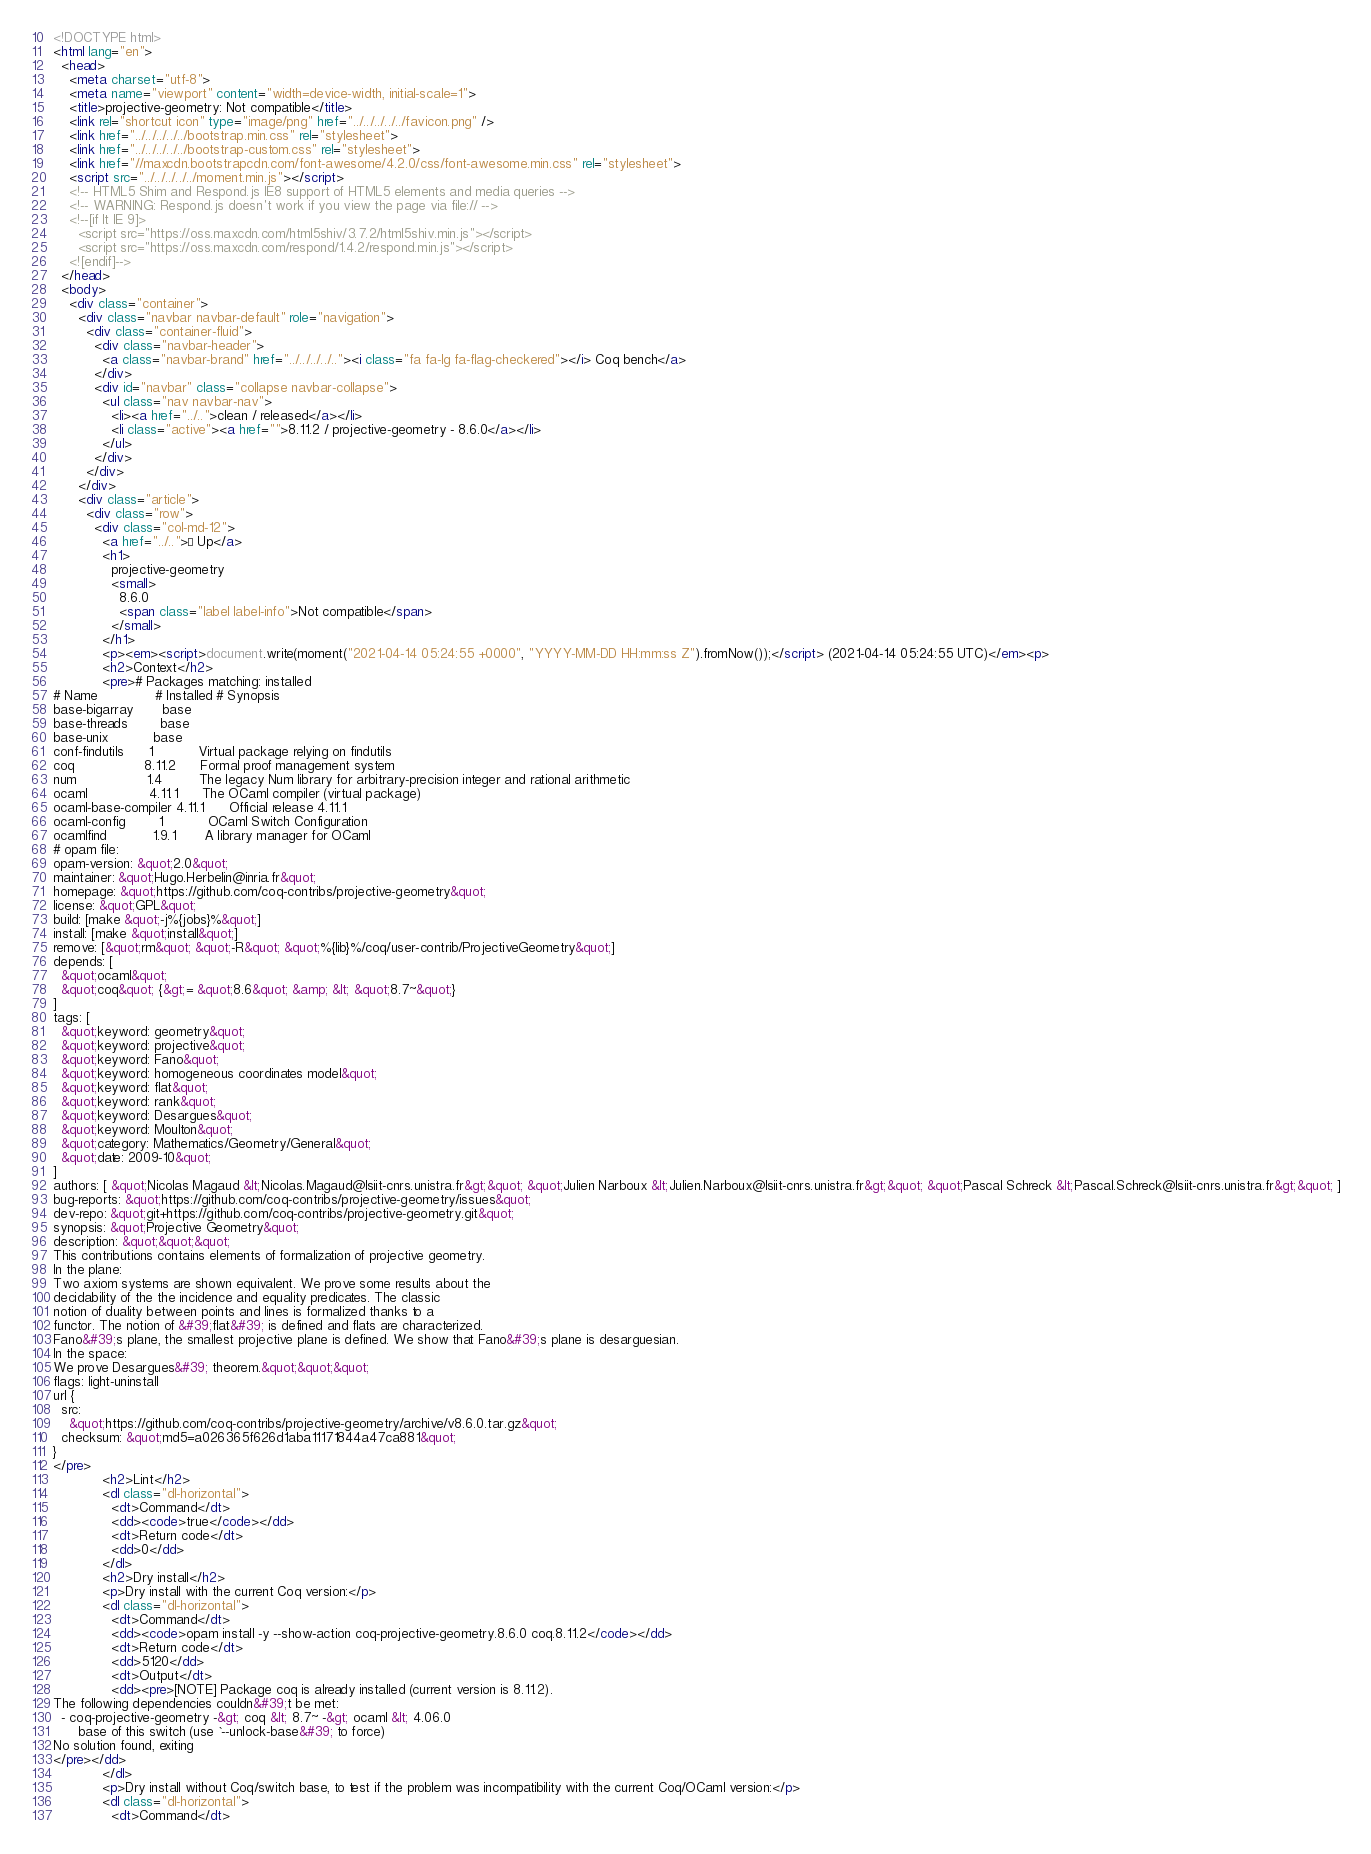Convert code to text. <code><loc_0><loc_0><loc_500><loc_500><_HTML_><!DOCTYPE html>
<html lang="en">
  <head>
    <meta charset="utf-8">
    <meta name="viewport" content="width=device-width, initial-scale=1">
    <title>projective-geometry: Not compatible</title>
    <link rel="shortcut icon" type="image/png" href="../../../../../favicon.png" />
    <link href="../../../../../bootstrap.min.css" rel="stylesheet">
    <link href="../../../../../bootstrap-custom.css" rel="stylesheet">
    <link href="//maxcdn.bootstrapcdn.com/font-awesome/4.2.0/css/font-awesome.min.css" rel="stylesheet">
    <script src="../../../../../moment.min.js"></script>
    <!-- HTML5 Shim and Respond.js IE8 support of HTML5 elements and media queries -->
    <!-- WARNING: Respond.js doesn't work if you view the page via file:// -->
    <!--[if lt IE 9]>
      <script src="https://oss.maxcdn.com/html5shiv/3.7.2/html5shiv.min.js"></script>
      <script src="https://oss.maxcdn.com/respond/1.4.2/respond.min.js"></script>
    <![endif]-->
  </head>
  <body>
    <div class="container">
      <div class="navbar navbar-default" role="navigation">
        <div class="container-fluid">
          <div class="navbar-header">
            <a class="navbar-brand" href="../../../../.."><i class="fa fa-lg fa-flag-checkered"></i> Coq bench</a>
          </div>
          <div id="navbar" class="collapse navbar-collapse">
            <ul class="nav navbar-nav">
              <li><a href="../..">clean / released</a></li>
              <li class="active"><a href="">8.11.2 / projective-geometry - 8.6.0</a></li>
            </ul>
          </div>
        </div>
      </div>
      <div class="article">
        <div class="row">
          <div class="col-md-12">
            <a href="../..">« Up</a>
            <h1>
              projective-geometry
              <small>
                8.6.0
                <span class="label label-info">Not compatible</span>
              </small>
            </h1>
            <p><em><script>document.write(moment("2021-04-14 05:24:55 +0000", "YYYY-MM-DD HH:mm:ss Z").fromNow());</script> (2021-04-14 05:24:55 UTC)</em><p>
            <h2>Context</h2>
            <pre># Packages matching: installed
# Name              # Installed # Synopsis
base-bigarray       base
base-threads        base
base-unix           base
conf-findutils      1           Virtual package relying on findutils
coq                 8.11.2      Formal proof management system
num                 1.4         The legacy Num library for arbitrary-precision integer and rational arithmetic
ocaml               4.11.1      The OCaml compiler (virtual package)
ocaml-base-compiler 4.11.1      Official release 4.11.1
ocaml-config        1           OCaml Switch Configuration
ocamlfind           1.9.1       A library manager for OCaml
# opam file:
opam-version: &quot;2.0&quot;
maintainer: &quot;Hugo.Herbelin@inria.fr&quot;
homepage: &quot;https://github.com/coq-contribs/projective-geometry&quot;
license: &quot;GPL&quot;
build: [make &quot;-j%{jobs}%&quot;]
install: [make &quot;install&quot;]
remove: [&quot;rm&quot; &quot;-R&quot; &quot;%{lib}%/coq/user-contrib/ProjectiveGeometry&quot;]
depends: [
  &quot;ocaml&quot;
  &quot;coq&quot; {&gt;= &quot;8.6&quot; &amp; &lt; &quot;8.7~&quot;}
]
tags: [
  &quot;keyword: geometry&quot;
  &quot;keyword: projective&quot;
  &quot;keyword: Fano&quot;
  &quot;keyword: homogeneous coordinates model&quot;
  &quot;keyword: flat&quot;
  &quot;keyword: rank&quot;
  &quot;keyword: Desargues&quot;
  &quot;keyword: Moulton&quot;
  &quot;category: Mathematics/Geometry/General&quot;
  &quot;date: 2009-10&quot;
]
authors: [ &quot;Nicolas Magaud &lt;Nicolas.Magaud@lsiit-cnrs.unistra.fr&gt;&quot; &quot;Julien Narboux &lt;Julien.Narboux@lsiit-cnrs.unistra.fr&gt;&quot; &quot;Pascal Schreck &lt;Pascal.Schreck@lsiit-cnrs.unistra.fr&gt;&quot; ]
bug-reports: &quot;https://github.com/coq-contribs/projective-geometry/issues&quot;
dev-repo: &quot;git+https://github.com/coq-contribs/projective-geometry.git&quot;
synopsis: &quot;Projective Geometry&quot;
description: &quot;&quot;&quot;
This contributions contains elements of formalization of projective geometry.
In the plane:
Two axiom systems are shown equivalent. We prove some results about the
decidability of the the incidence and equality predicates. The classic
notion of duality between points and lines is formalized thanks to a
functor. The notion of &#39;flat&#39; is defined and flats are characterized.
Fano&#39;s plane, the smallest projective plane is defined. We show that Fano&#39;s plane is desarguesian.
In the space:
We prove Desargues&#39; theorem.&quot;&quot;&quot;
flags: light-uninstall
url {
  src:
    &quot;https://github.com/coq-contribs/projective-geometry/archive/v8.6.0.tar.gz&quot;
  checksum: &quot;md5=a026365f626d1aba11171844a47ca881&quot;
}
</pre>
            <h2>Lint</h2>
            <dl class="dl-horizontal">
              <dt>Command</dt>
              <dd><code>true</code></dd>
              <dt>Return code</dt>
              <dd>0</dd>
            </dl>
            <h2>Dry install</h2>
            <p>Dry install with the current Coq version:</p>
            <dl class="dl-horizontal">
              <dt>Command</dt>
              <dd><code>opam install -y --show-action coq-projective-geometry.8.6.0 coq.8.11.2</code></dd>
              <dt>Return code</dt>
              <dd>5120</dd>
              <dt>Output</dt>
              <dd><pre>[NOTE] Package coq is already installed (current version is 8.11.2).
The following dependencies couldn&#39;t be met:
  - coq-projective-geometry -&gt; coq &lt; 8.7~ -&gt; ocaml &lt; 4.06.0
      base of this switch (use `--unlock-base&#39; to force)
No solution found, exiting
</pre></dd>
            </dl>
            <p>Dry install without Coq/switch base, to test if the problem was incompatibility with the current Coq/OCaml version:</p>
            <dl class="dl-horizontal">
              <dt>Command</dt></code> 